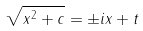Convert formula to latex. <formula><loc_0><loc_0><loc_500><loc_500>\sqrt { x ^ { 2 } + c } = \pm i x + t</formula> 